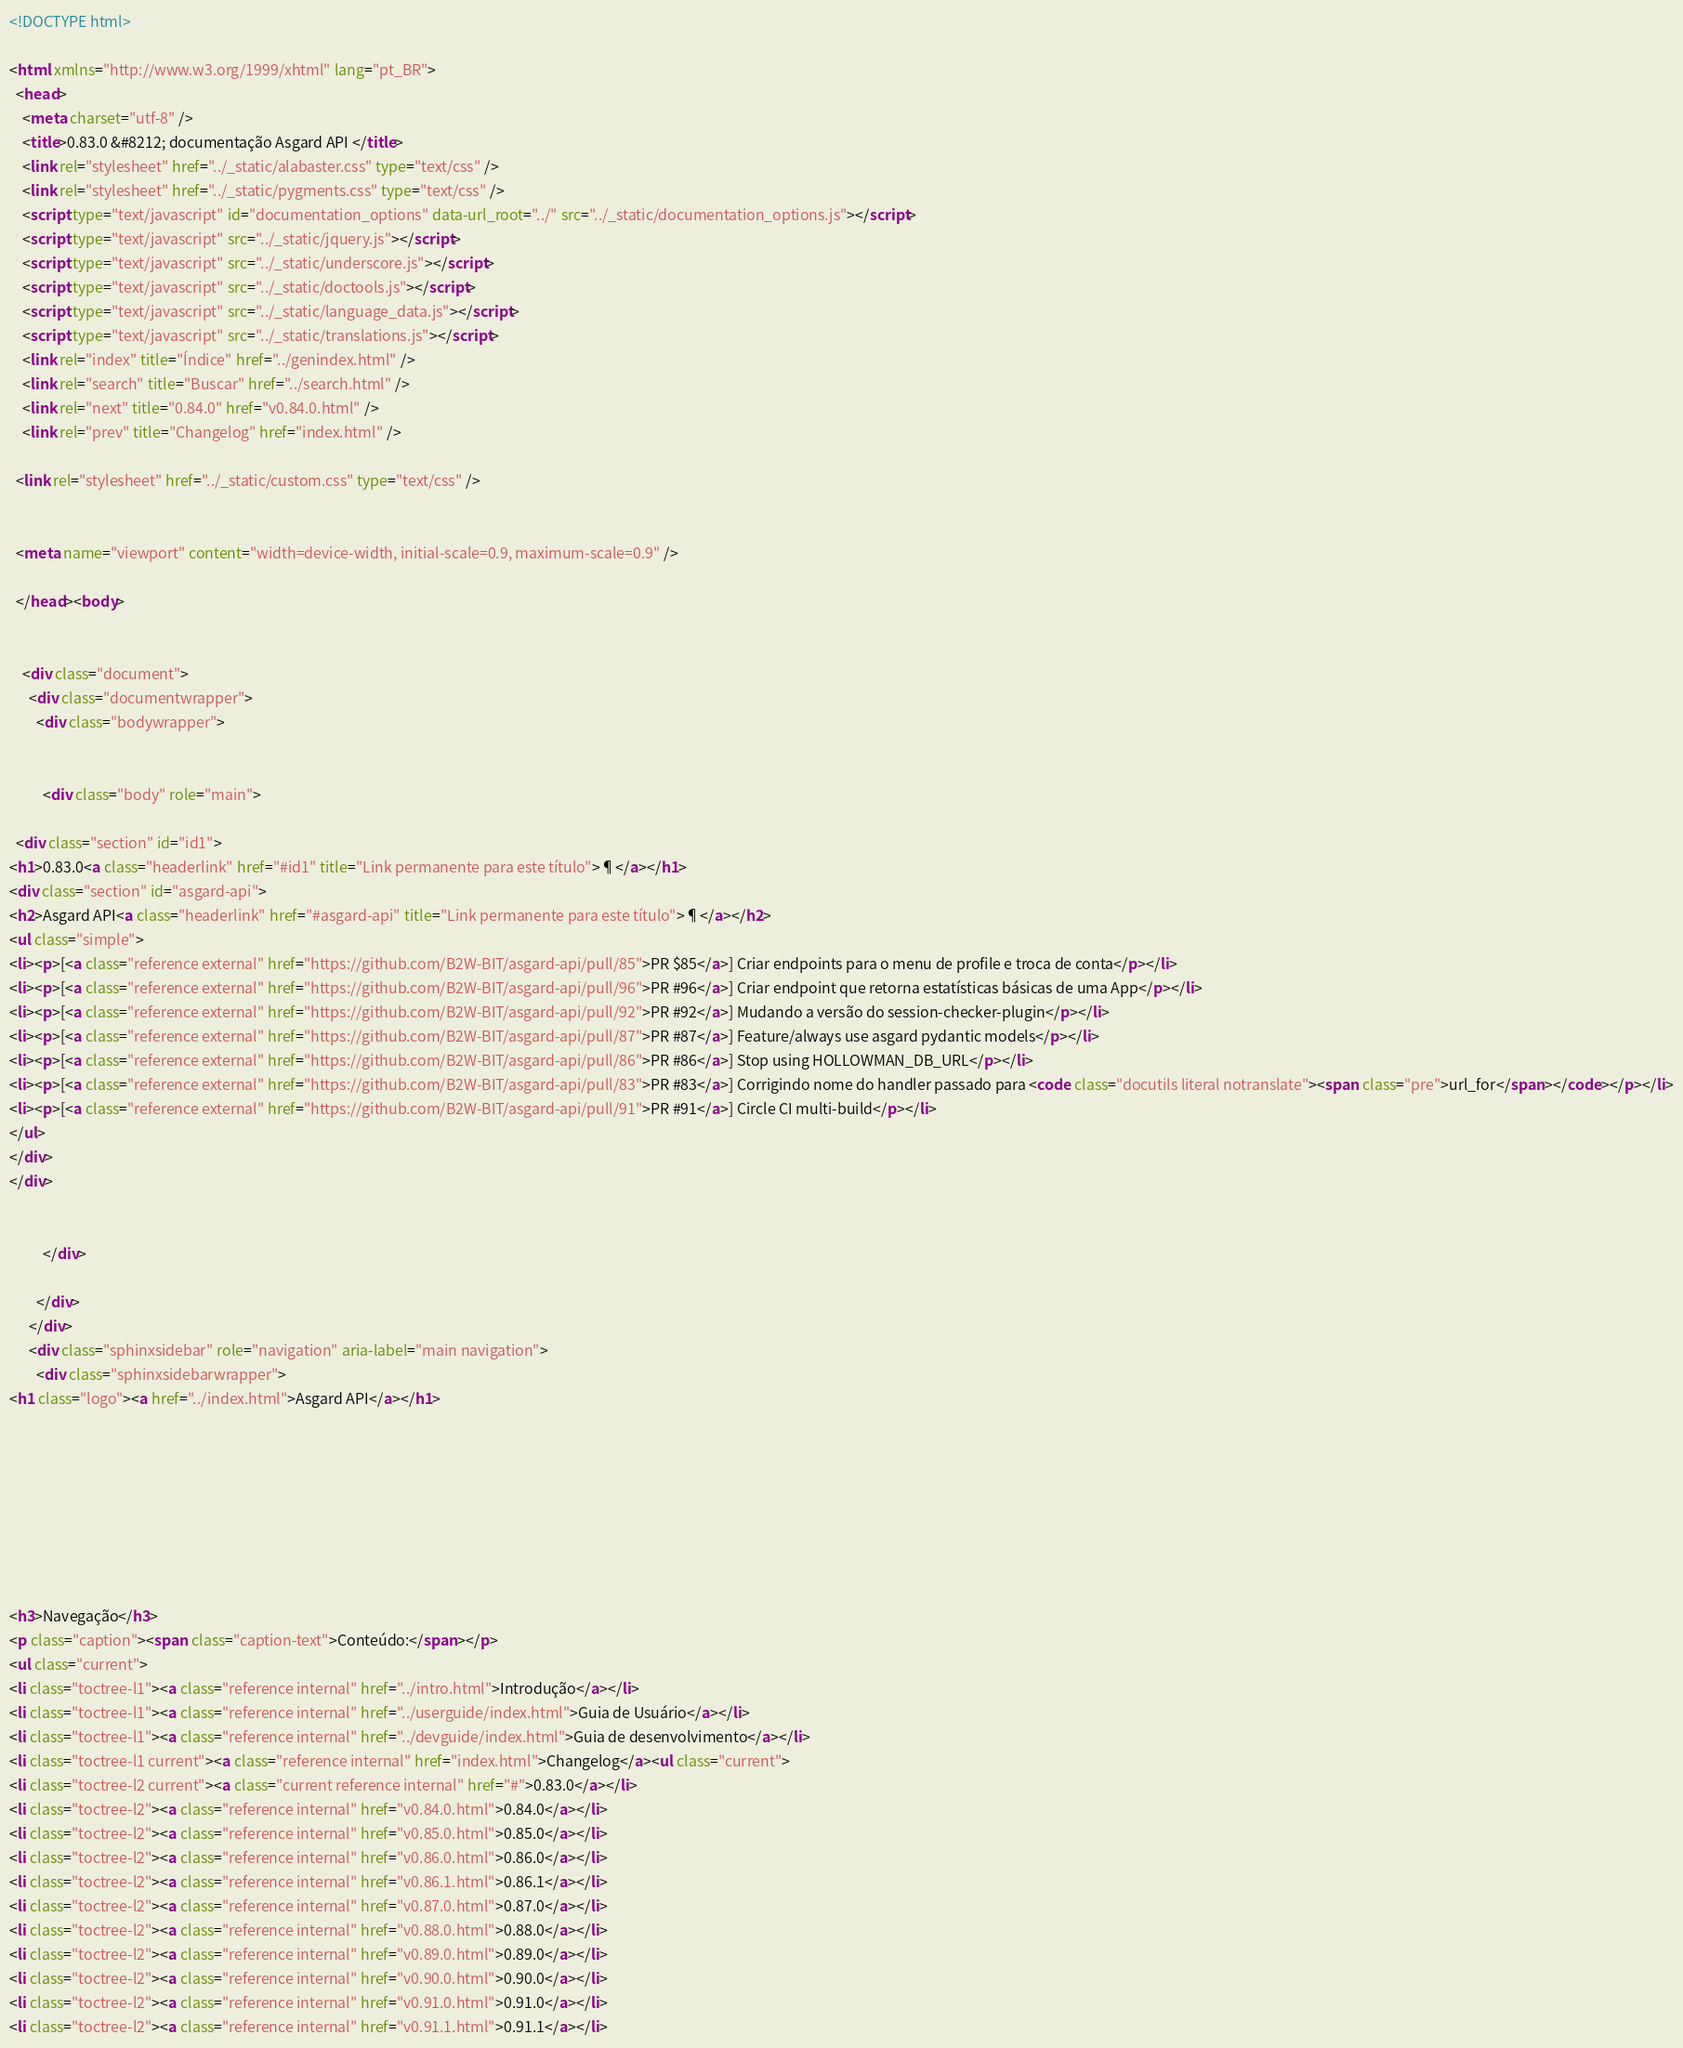<code> <loc_0><loc_0><loc_500><loc_500><_HTML_>
<!DOCTYPE html>

<html xmlns="http://www.w3.org/1999/xhtml" lang="pt_BR">
  <head>
    <meta charset="utf-8" />
    <title>0.83.0 &#8212; documentação Asgard API </title>
    <link rel="stylesheet" href="../_static/alabaster.css" type="text/css" />
    <link rel="stylesheet" href="../_static/pygments.css" type="text/css" />
    <script type="text/javascript" id="documentation_options" data-url_root="../" src="../_static/documentation_options.js"></script>
    <script type="text/javascript" src="../_static/jquery.js"></script>
    <script type="text/javascript" src="../_static/underscore.js"></script>
    <script type="text/javascript" src="../_static/doctools.js"></script>
    <script type="text/javascript" src="../_static/language_data.js"></script>
    <script type="text/javascript" src="../_static/translations.js"></script>
    <link rel="index" title="Índice" href="../genindex.html" />
    <link rel="search" title="Buscar" href="../search.html" />
    <link rel="next" title="0.84.0" href="v0.84.0.html" />
    <link rel="prev" title="Changelog" href="index.html" />
   
  <link rel="stylesheet" href="../_static/custom.css" type="text/css" />
  
  
  <meta name="viewport" content="width=device-width, initial-scale=0.9, maximum-scale=0.9" />

  </head><body>
  

    <div class="document">
      <div class="documentwrapper">
        <div class="bodywrapper">
          

          <div class="body" role="main">
            
  <div class="section" id="id1">
<h1>0.83.0<a class="headerlink" href="#id1" title="Link permanente para este título">¶</a></h1>
<div class="section" id="asgard-api">
<h2>Asgard API<a class="headerlink" href="#asgard-api" title="Link permanente para este título">¶</a></h2>
<ul class="simple">
<li><p>[<a class="reference external" href="https://github.com/B2W-BIT/asgard-api/pull/85">PR $85</a>] Criar endpoints para o menu de profile e troca de conta</p></li>
<li><p>[<a class="reference external" href="https://github.com/B2W-BIT/asgard-api/pull/96">PR #96</a>] Criar endpoint que retorna estatísticas básicas de uma App</p></li>
<li><p>[<a class="reference external" href="https://github.com/B2W-BIT/asgard-api/pull/92">PR #92</a>] Mudando a versão do session-checker-plugin</p></li>
<li><p>[<a class="reference external" href="https://github.com/B2W-BIT/asgard-api/pull/87">PR #87</a>] Feature/always use asgard pydantic models</p></li>
<li><p>[<a class="reference external" href="https://github.com/B2W-BIT/asgard-api/pull/86">PR #86</a>] Stop using HOLLOWMAN_DB_URL</p></li>
<li><p>[<a class="reference external" href="https://github.com/B2W-BIT/asgard-api/pull/83">PR #83</a>] Corrigindo nome do handler passado para <code class="docutils literal notranslate"><span class="pre">url_for</span></code></p></li>
<li><p>[<a class="reference external" href="https://github.com/B2W-BIT/asgard-api/pull/91">PR #91</a>] Circle CI multi-build</p></li>
</ul>
</div>
</div>


          </div>
          
        </div>
      </div>
      <div class="sphinxsidebar" role="navigation" aria-label="main navigation">
        <div class="sphinxsidebarwrapper">
<h1 class="logo"><a href="../index.html">Asgard API</a></h1>








<h3>Navegação</h3>
<p class="caption"><span class="caption-text">Conteúdo:</span></p>
<ul class="current">
<li class="toctree-l1"><a class="reference internal" href="../intro.html">Introdução</a></li>
<li class="toctree-l1"><a class="reference internal" href="../userguide/index.html">Guia de Usuário</a></li>
<li class="toctree-l1"><a class="reference internal" href="../devguide/index.html">Guia de desenvolvimento</a></li>
<li class="toctree-l1 current"><a class="reference internal" href="index.html">Changelog</a><ul class="current">
<li class="toctree-l2 current"><a class="current reference internal" href="#">0.83.0</a></li>
<li class="toctree-l2"><a class="reference internal" href="v0.84.0.html">0.84.0</a></li>
<li class="toctree-l2"><a class="reference internal" href="v0.85.0.html">0.85.0</a></li>
<li class="toctree-l2"><a class="reference internal" href="v0.86.0.html">0.86.0</a></li>
<li class="toctree-l2"><a class="reference internal" href="v0.86.1.html">0.86.1</a></li>
<li class="toctree-l2"><a class="reference internal" href="v0.87.0.html">0.87.0</a></li>
<li class="toctree-l2"><a class="reference internal" href="v0.88.0.html">0.88.0</a></li>
<li class="toctree-l2"><a class="reference internal" href="v0.89.0.html">0.89.0</a></li>
<li class="toctree-l2"><a class="reference internal" href="v0.90.0.html">0.90.0</a></li>
<li class="toctree-l2"><a class="reference internal" href="v0.91.0.html">0.91.0</a></li>
<li class="toctree-l2"><a class="reference internal" href="v0.91.1.html">0.91.1</a></li></code> 